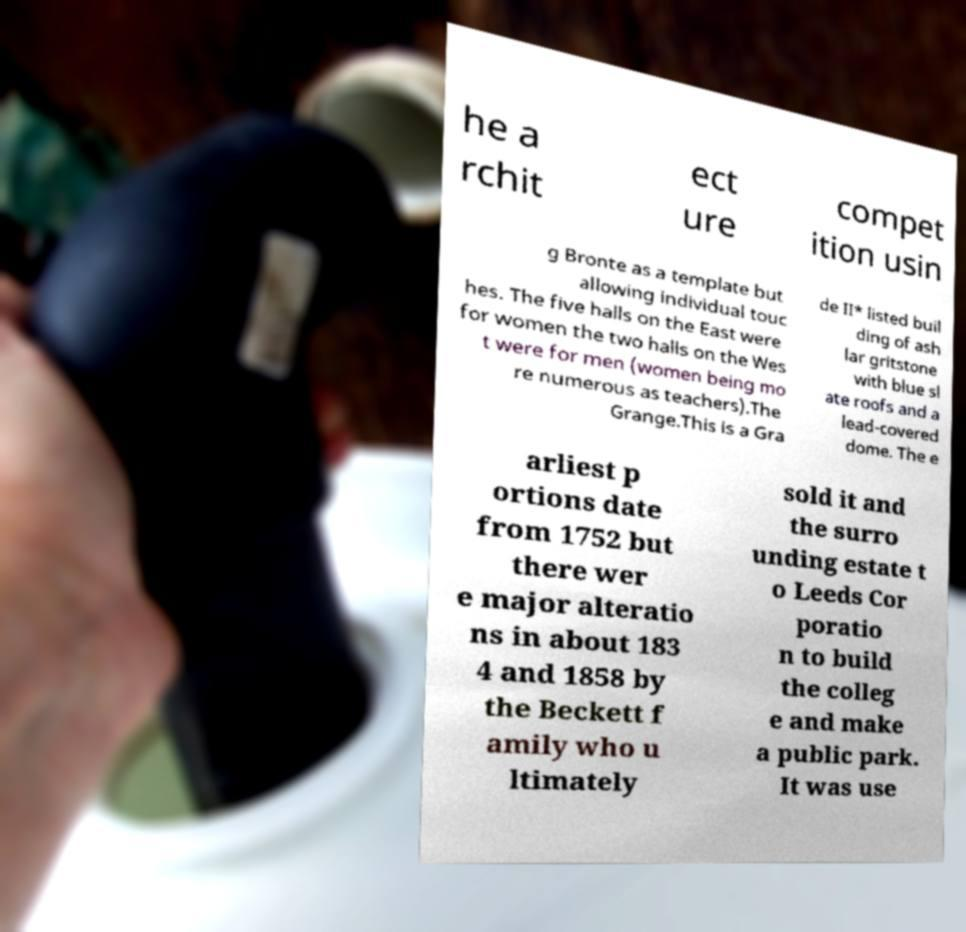There's text embedded in this image that I need extracted. Can you transcribe it verbatim? he a rchit ect ure compet ition usin g Bronte as a template but allowing individual touc hes. The five halls on the East were for women the two halls on the Wes t were for men (women being mo re numerous as teachers).The Grange.This is a Gra de II* listed buil ding of ash lar gritstone with blue sl ate roofs and a lead-covered dome. The e arliest p ortions date from 1752 but there wer e major alteratio ns in about 183 4 and 1858 by the Beckett f amily who u ltimately sold it and the surro unding estate t o Leeds Cor poratio n to build the colleg e and make a public park. It was use 